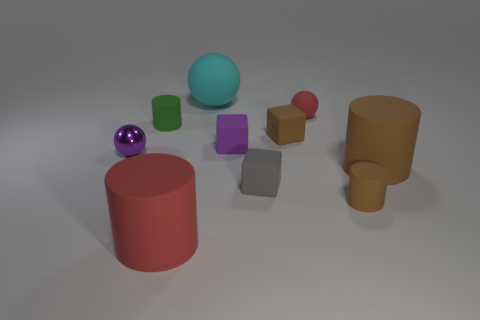Subtract all red balls. How many balls are left? 2 Subtract all brown blocks. How many brown cylinders are left? 2 Subtract all brown cubes. How many cubes are left? 2 Subtract all spheres. How many objects are left? 7 Subtract 1 balls. How many balls are left? 2 Subtract all red cylinders. Subtract all purple spheres. How many cylinders are left? 3 Subtract all brown cubes. Subtract all purple matte things. How many objects are left? 8 Add 1 brown rubber things. How many brown rubber things are left? 4 Add 2 tiny cubes. How many tiny cubes exist? 5 Subtract 0 green cubes. How many objects are left? 10 